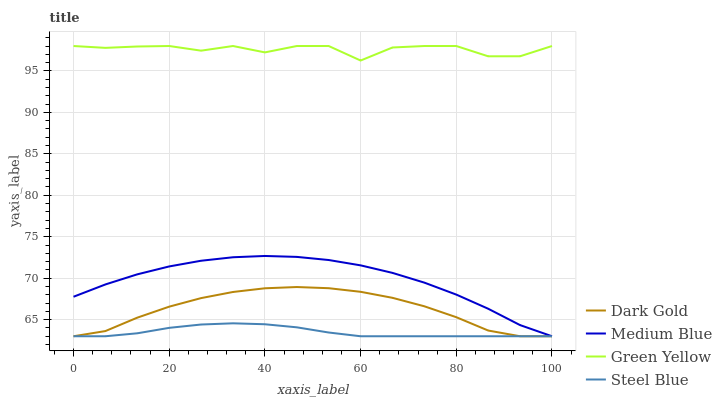Does Steel Blue have the minimum area under the curve?
Answer yes or no. Yes. Does Green Yellow have the maximum area under the curve?
Answer yes or no. Yes. Does Medium Blue have the minimum area under the curve?
Answer yes or no. No. Does Medium Blue have the maximum area under the curve?
Answer yes or no. No. Is Steel Blue the smoothest?
Answer yes or no. Yes. Is Green Yellow the roughest?
Answer yes or no. Yes. Is Medium Blue the smoothest?
Answer yes or no. No. Is Medium Blue the roughest?
Answer yes or no. No. Does Medium Blue have the lowest value?
Answer yes or no. Yes. Does Green Yellow have the highest value?
Answer yes or no. Yes. Does Medium Blue have the highest value?
Answer yes or no. No. Is Dark Gold less than Green Yellow?
Answer yes or no. Yes. Is Green Yellow greater than Dark Gold?
Answer yes or no. Yes. Does Medium Blue intersect Dark Gold?
Answer yes or no. Yes. Is Medium Blue less than Dark Gold?
Answer yes or no. No. Is Medium Blue greater than Dark Gold?
Answer yes or no. No. Does Dark Gold intersect Green Yellow?
Answer yes or no. No. 